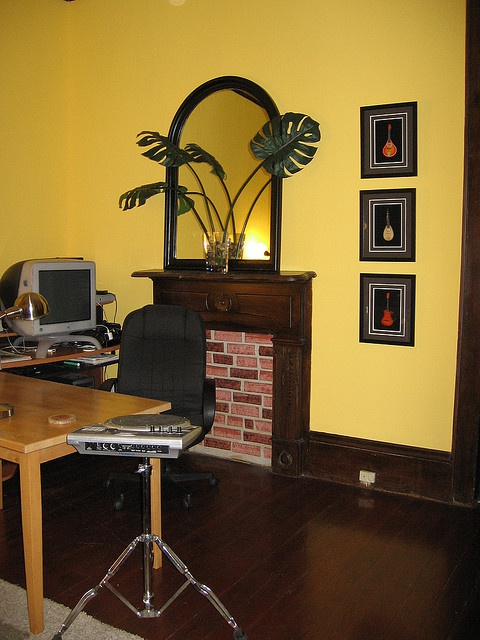Describe the objects in this image and their specific colors. I can see potted plant in olive and black tones, chair in olive, black, brown, gray, and maroon tones, tv in olive, black, and gray tones, vase in olive, black, and maroon tones, and remote in olive, black, and tan tones in this image. 